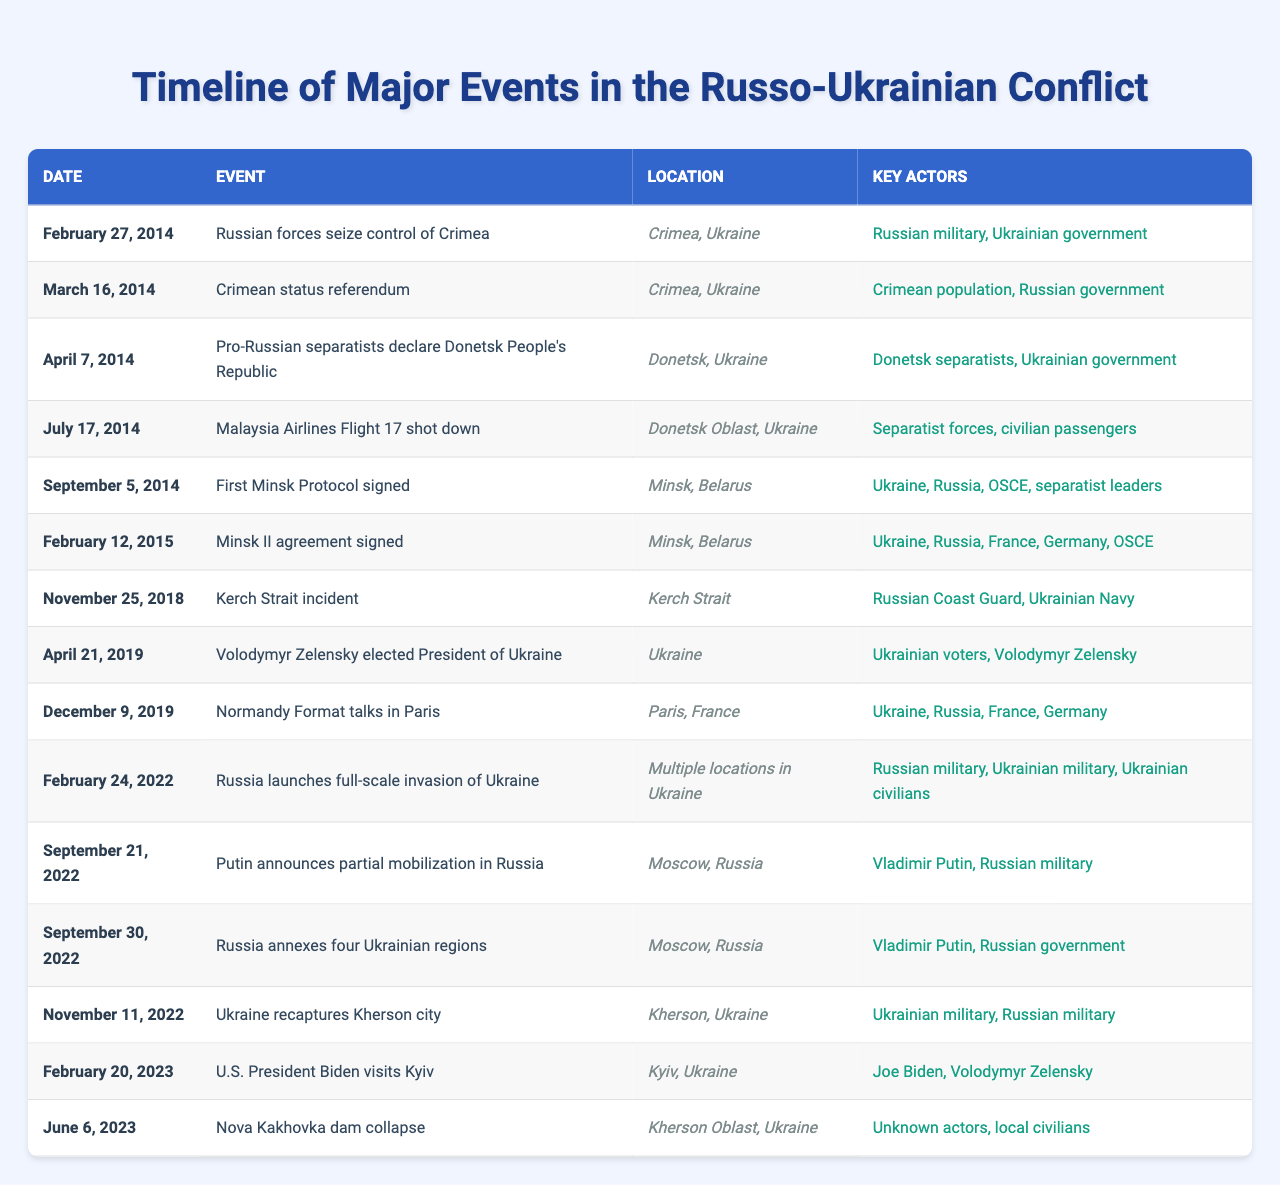What event occurred on February 27, 2014? The table shows that on February 27, 2014, Russian forces seized control of Crimea.
Answer: Russian forces seize control of Crimea Which countries were involved in the signing of the Minsk II agreement on February 12, 2015? The table indicates that the key actors in the Minsk II agreement included Ukraine, Russia, France, Germany, and OSCE.
Answer: Ukraine, Russia, France, Germany, OSCE How many months are there between the annexation of four Ukrainian regions and the recapture of Kherson city? The annexation of four regions occurred on September 30, 2022, and Kherson was recaptured on November 11, 2022. This is a duration of 1 month and 11 days, which totals to roughly 1.5 months.
Answer: Approximately 1.5 months Was the Kerch Strait incident associated with the Ukrainian Navy? According to the table, the Kerch Strait incident involved the Russian Coast Guard and the Ukrainian Navy as key actors.
Answer: Yes Identify the date of the full-scale invasion of Ukraine by Russia. The table provides the date for the full-scale invasion as February 24, 2022.
Answer: February 24, 2022 How many events listed occurred in 2014? By reviewing the table, four events are noted in 2014: the seizure of Crimea, the Crimean referendum, the declaration of the Donetsk People's Republic, and the shooting down of Malaysia Airlines Flight 17.
Answer: Four events What was the main focus of the Normandy Format talks in Paris on December 9, 2019? The table shows that the key actors in the Normandy Format talks were Ukraine, Russia, France, and Germany, indicating that the focus was likely on negotiations related to the conflict.
Answer: Negotiations related to the conflict Which event involved civilian passengers and when did it occur? The event that involved civilian passengers was the shooting down of Malaysia Airlines Flight 17 on July 17, 2014.
Answer: July 17, 2014 Who was elected President of Ukraine in April 2019? The table states that Volodymyr Zelensky was elected as President of Ukraine on April 21, 2019.
Answer: Volodymyr Zelensky Was there a significant event involving the US President in 2023 according to the table? The table lists an event where U.S. President Biden visited Kyiv on February 20, 2023, indicating it was indeed significant.
Answer: Yes 